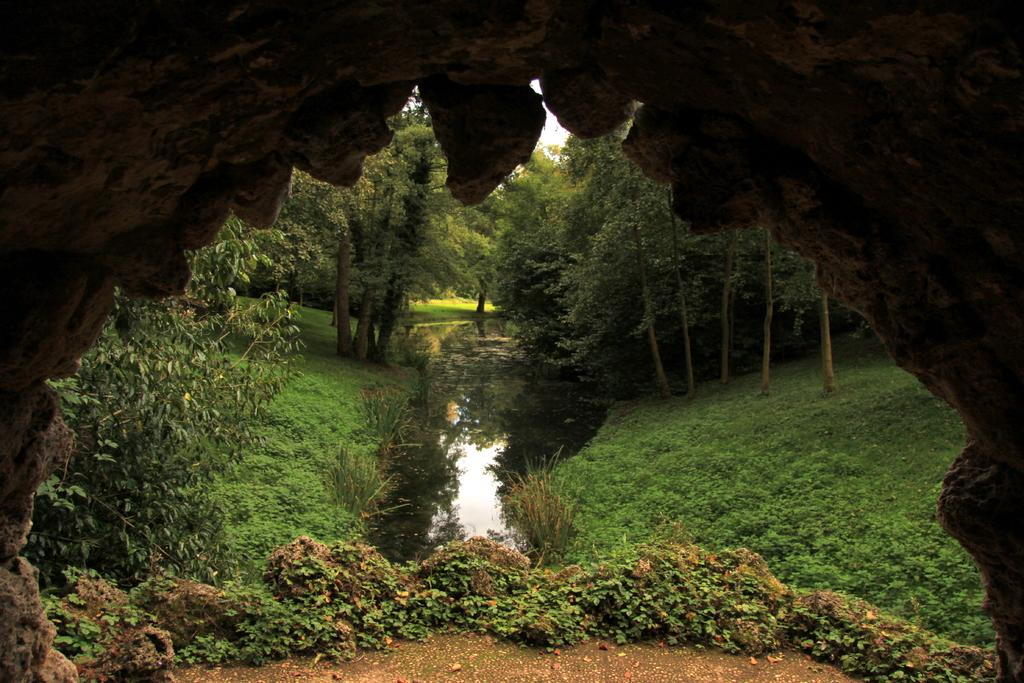What type of vegetation can be seen in the image? There is grass, plants, and trees in the image. Can you describe the natural environment depicted in the image? The image features a variety of vegetation, including grass, plants, and trees. What type of print can be seen on the leaves of the plants in the image? There is no print visible on the leaves of the plants in the image. 